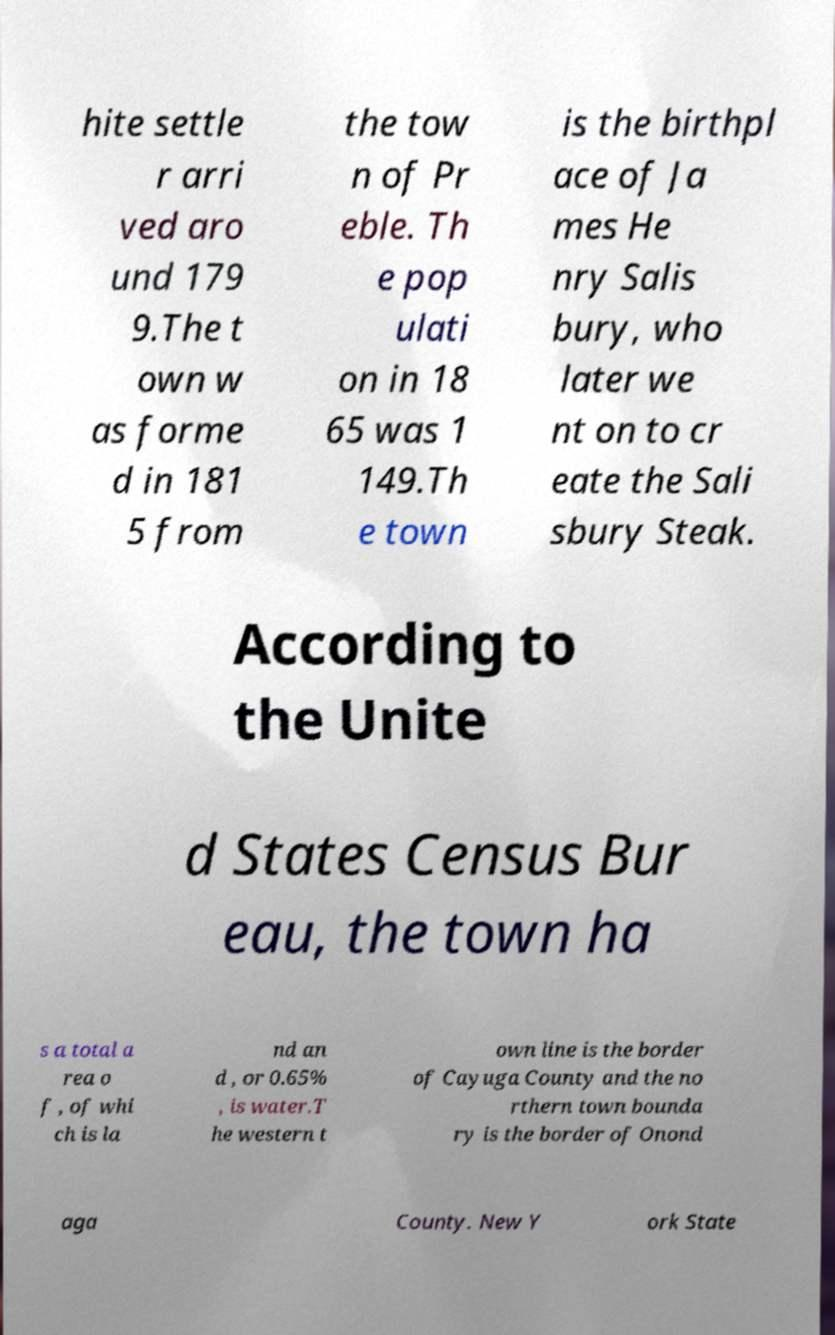Please identify and transcribe the text found in this image. hite settle r arri ved aro und 179 9.The t own w as forme d in 181 5 from the tow n of Pr eble. Th e pop ulati on in 18 65 was 1 149.Th e town is the birthpl ace of Ja mes He nry Salis bury, who later we nt on to cr eate the Sali sbury Steak. According to the Unite d States Census Bur eau, the town ha s a total a rea o f , of whi ch is la nd an d , or 0.65% , is water.T he western t own line is the border of Cayuga County and the no rthern town bounda ry is the border of Onond aga County. New Y ork State 